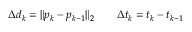<formula> <loc_0><loc_0><loc_500><loc_500>\Delta { d } _ { k } = \| p _ { k } - p _ { k - 1 } \| _ { 2 } \quad \Delta { t } _ { k } = t _ { k } - t _ { k - 1 }</formula> 